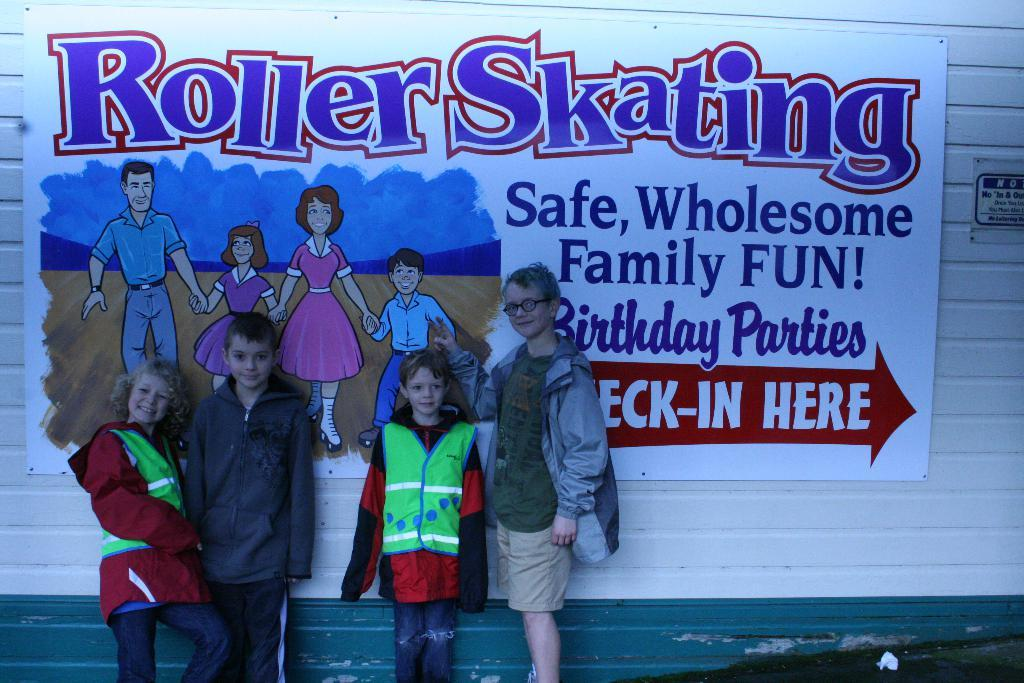Provide a one-sentence caption for the provided image. four kids in front of sign for roller skating and it has an arrow pointing to where you can check-in. 